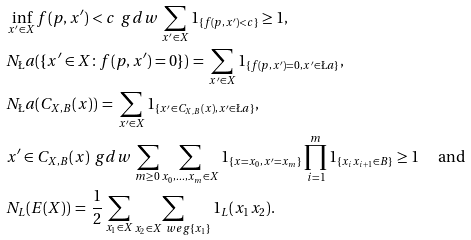Convert formula to latex. <formula><loc_0><loc_0><loc_500><loc_500>& \inf _ { x ^ { \prime } \in X } f ( p , x ^ { \prime } ) < c \, \ g d w \, \sum _ { x ^ { \prime } \in X } 1 _ { \{ f ( p , x ^ { \prime } ) < c \} } \geq 1 , \\ & N _ { \L } a ( \{ x ^ { \prime } \in X \colon f ( p , x ^ { \prime } ) = 0 \} ) \, = \, \sum _ { x ^ { \prime } \in X } 1 _ { \{ f ( p , x ^ { \prime } ) = 0 , x ^ { \prime } \in \L a \} } , \\ & N _ { \L } a ( C _ { X , B } ( x ) ) \, = \, \sum _ { x ^ { \prime } \in X } 1 _ { \{ x ^ { \prime } \in C _ { X , B } ( x ) , x ^ { \prime } \in \L a \} } , \\ & x ^ { \prime } \in C _ { X , B } ( x ) \, \ g d w \, \sum _ { m \geq 0 } \sum _ { x _ { 0 } , \dots , x _ { m } \in X } 1 _ { \{ x = x _ { 0 } , x ^ { \prime } = x _ { m } \} } \prod _ { i = 1 } ^ { m } 1 _ { \{ x _ { i } x _ { i + 1 } \in B \} } \geq 1 \quad \text { and } \\ & N _ { L } ( E ( X ) ) \, = \, \frac { 1 } { 2 } \sum _ { x _ { 1 } \in X } \sum _ { x _ { 2 } \in X \ w e g \{ x _ { 1 } \} } 1 _ { L } ( x _ { 1 } x _ { 2 } ) .</formula> 